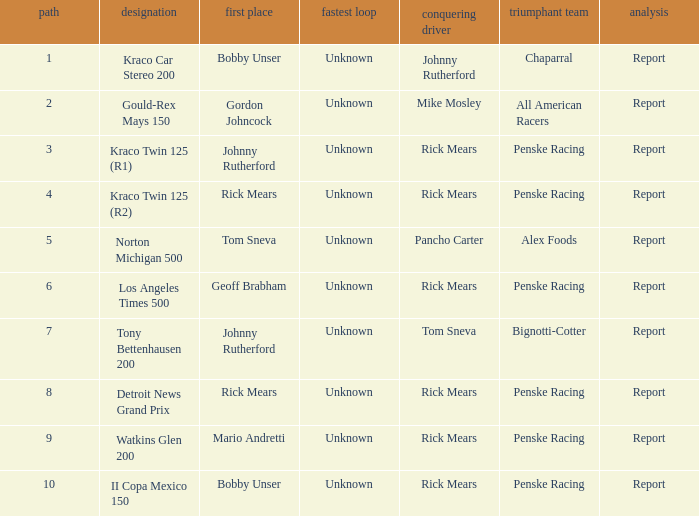Can you parse all the data within this table? {'header': ['path', 'designation', 'first place', 'fastest loop', 'conquering driver', 'triumphant team', 'analysis'], 'rows': [['1', 'Kraco Car Stereo 200', 'Bobby Unser', 'Unknown', 'Johnny Rutherford', 'Chaparral', 'Report'], ['2', 'Gould-Rex Mays 150', 'Gordon Johncock', 'Unknown', 'Mike Mosley', 'All American Racers', 'Report'], ['3', 'Kraco Twin 125 (R1)', 'Johnny Rutherford', 'Unknown', 'Rick Mears', 'Penske Racing', 'Report'], ['4', 'Kraco Twin 125 (R2)', 'Rick Mears', 'Unknown', 'Rick Mears', 'Penske Racing', 'Report'], ['5', 'Norton Michigan 500', 'Tom Sneva', 'Unknown', 'Pancho Carter', 'Alex Foods', 'Report'], ['6', 'Los Angeles Times 500', 'Geoff Brabham', 'Unknown', 'Rick Mears', 'Penske Racing', 'Report'], ['7', 'Tony Bettenhausen 200', 'Johnny Rutherford', 'Unknown', 'Tom Sneva', 'Bignotti-Cotter', 'Report'], ['8', 'Detroit News Grand Prix', 'Rick Mears', 'Unknown', 'Rick Mears', 'Penske Racing', 'Report'], ['9', 'Watkins Glen 200', 'Mario Andretti', 'Unknown', 'Rick Mears', 'Penske Racing', 'Report'], ['10', 'II Copa Mexico 150', 'Bobby Unser', 'Unknown', 'Rick Mears', 'Penske Racing', 'Report']]} The winning team of the race, los angeles times 500 is who? Penske Racing. 